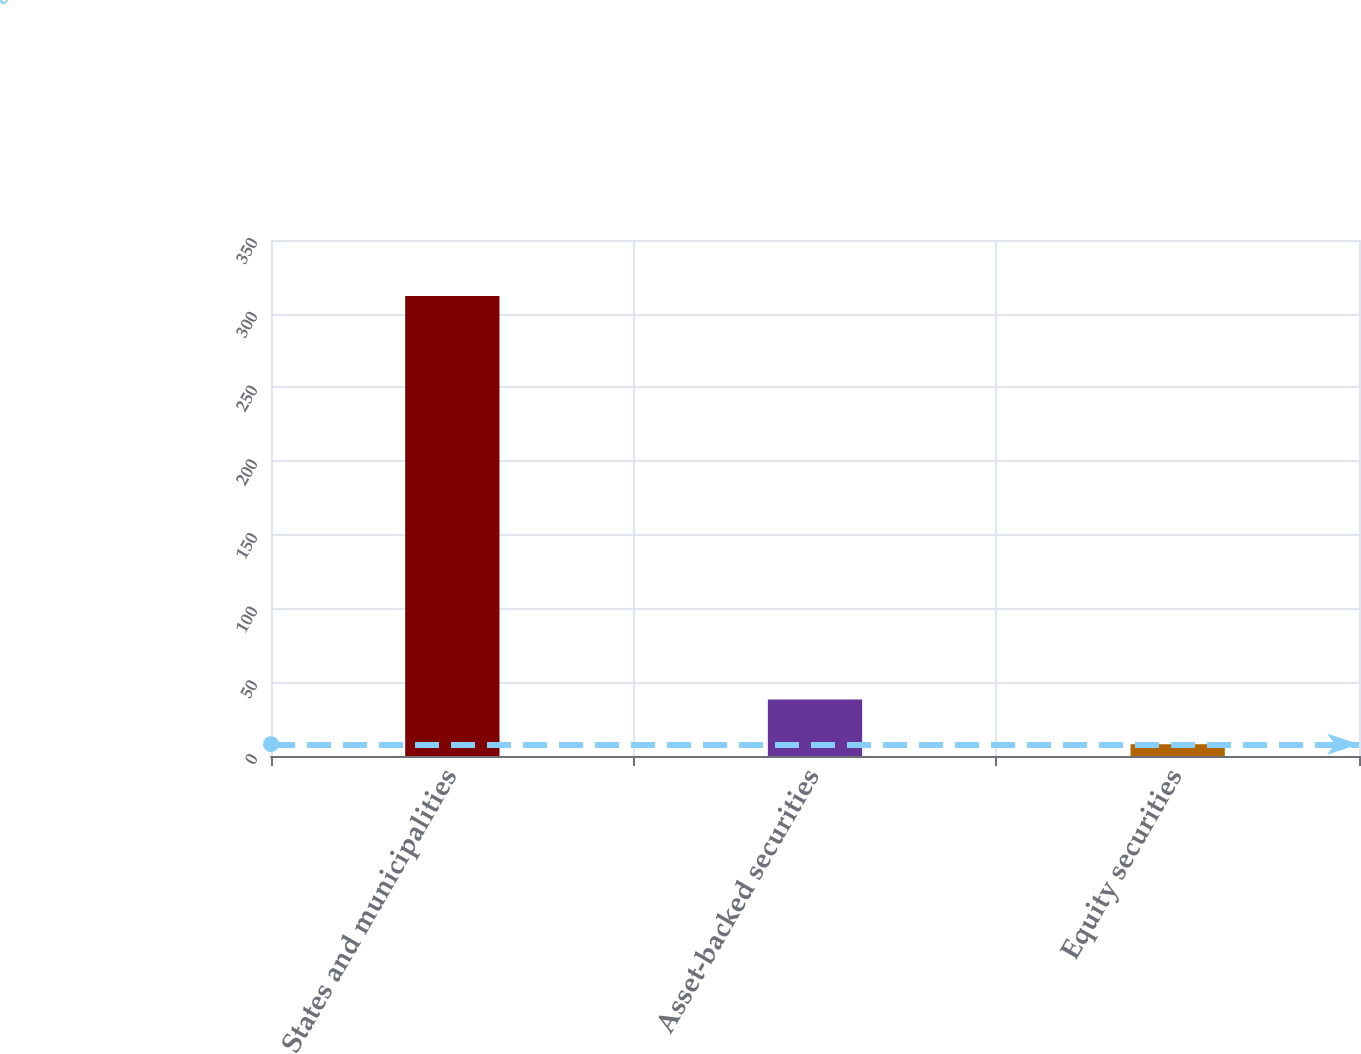Convert chart. <chart><loc_0><loc_0><loc_500><loc_500><bar_chart><fcel>States and municipalities<fcel>Asset-backed securities<fcel>Equity securities<nl><fcel>312<fcel>38.4<fcel>8<nl></chart> 